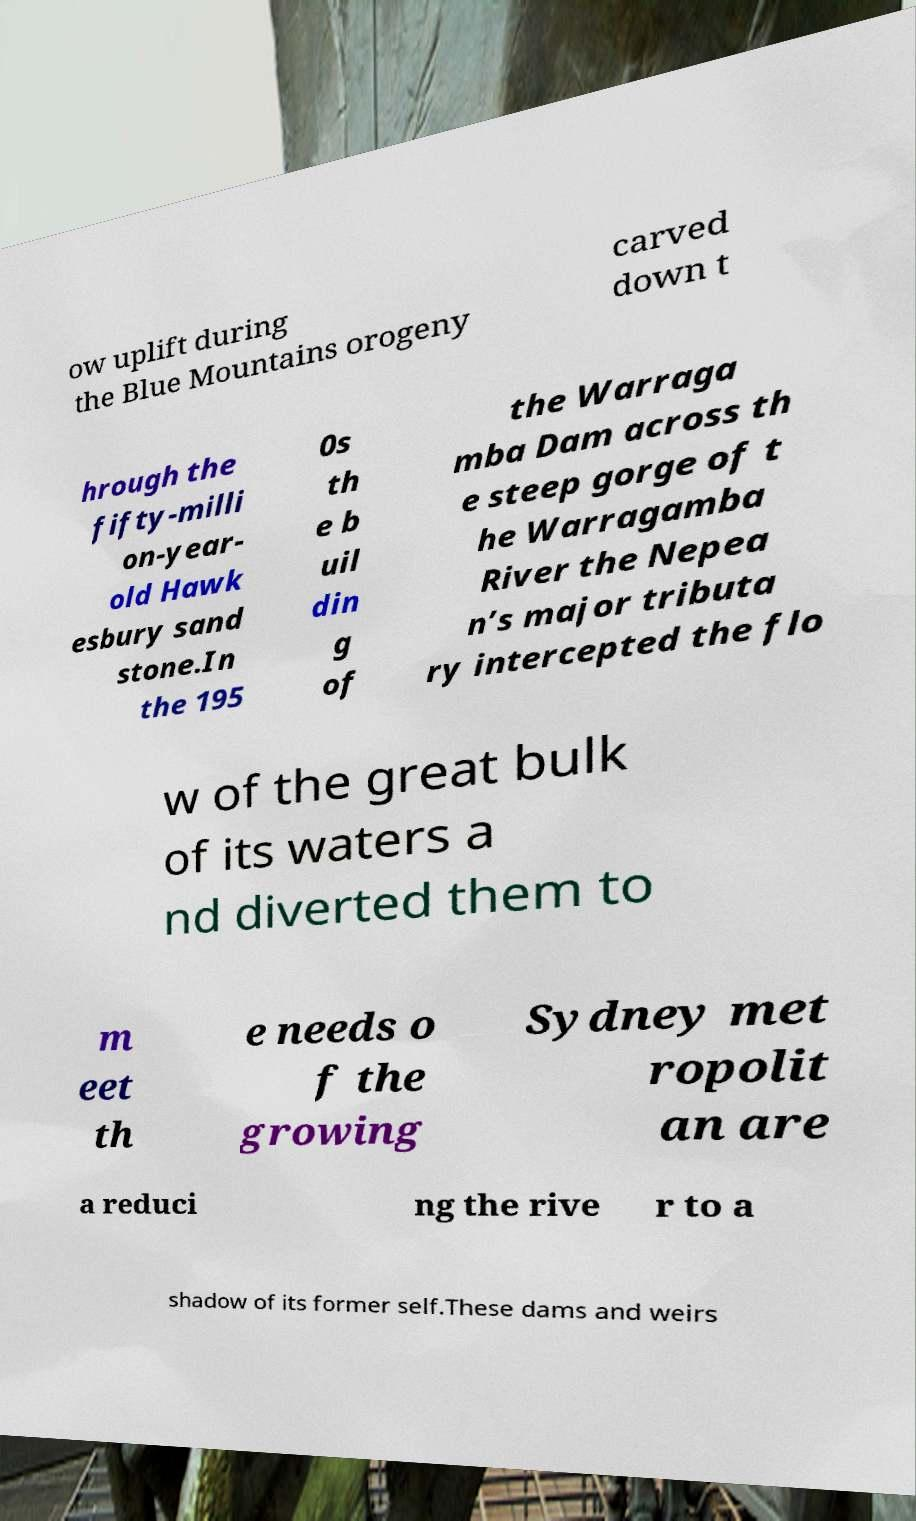What messages or text are displayed in this image? I need them in a readable, typed format. ow uplift during the Blue Mountains orogeny carved down t hrough the fifty-milli on-year- old Hawk esbury sand stone.In the 195 0s th e b uil din g of the Warraga mba Dam across th e steep gorge of t he Warragamba River the Nepea n’s major tributa ry intercepted the flo w of the great bulk of its waters a nd diverted them to m eet th e needs o f the growing Sydney met ropolit an are a reduci ng the rive r to a shadow of its former self.These dams and weirs 